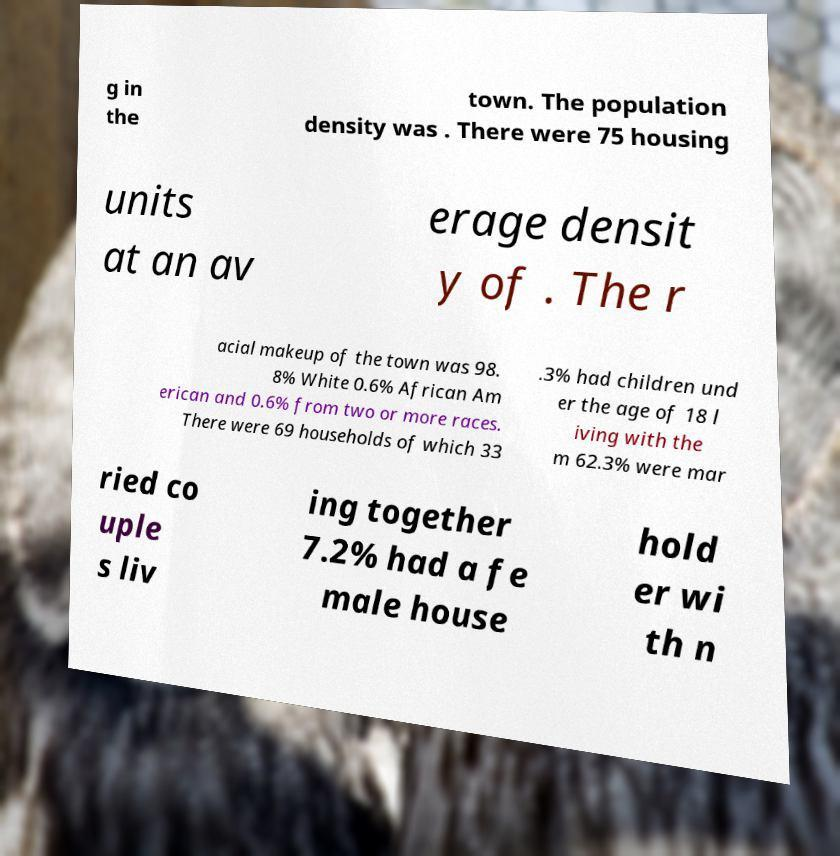Please identify and transcribe the text found in this image. g in the town. The population density was . There were 75 housing units at an av erage densit y of . The r acial makeup of the town was 98. 8% White 0.6% African Am erican and 0.6% from two or more races. There were 69 households of which 33 .3% had children und er the age of 18 l iving with the m 62.3% were mar ried co uple s liv ing together 7.2% had a fe male house hold er wi th n 